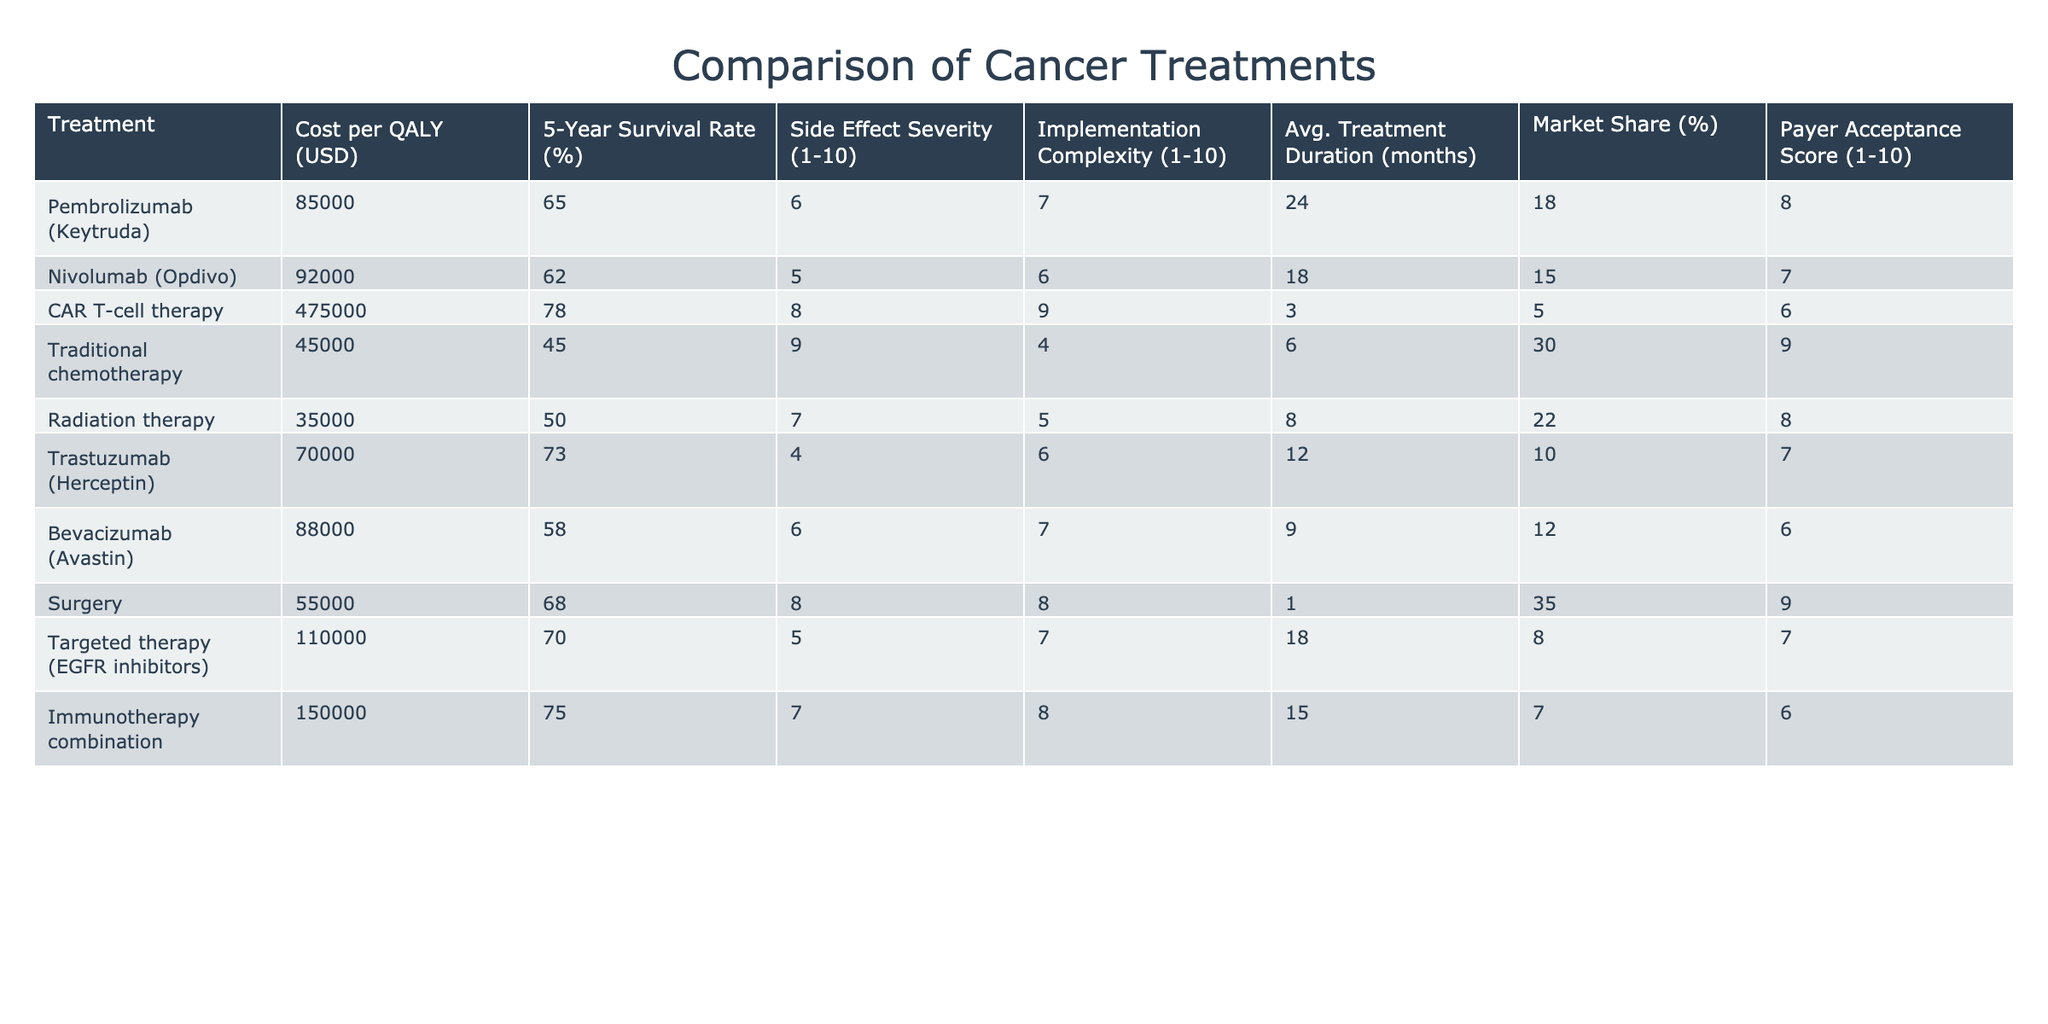What is the cost per QALY for Traditional chemotherapy? The table shows the cost per QALY for Traditional chemotherapy as 45000 USD.
Answer: 45000 Which treatment has the highest 5-Year Survival Rate? The highest 5-Year Survival Rate in the table belongs to CAR T-cell therapy at 78%.
Answer: 78% Is the average treatment duration for Immunotherapy combination longer than that for Radiation therapy? The average treatment duration for Immunotherapy combination is 15 months, while for Radiation therapy, it is 8 months. Since 15 is greater than 8, the statement is true.
Answer: Yes Calculate the average cost per QALY of the treatments listed. The cost per QALY values are: 85000, 92000, 475000, 45000, 35000, 70000, 88000, 55000, 110000, and 150000. Summing them gives  85000 + 92000 + 475000 + 45000 + 35000 + 70000 + 88000 + 55000 + 110000 + 150000 = 1005000. Dividing by the number of treatments (10) gives an average of 1005000/10 = 100500.
Answer: 100500 Does Surgery have a higher Payer Acceptance Score than Targeted therapy (EGFR inhibitors)? The Payer Acceptance Score for Surgery is 9, while for Targeted therapy (EGFR inhibitors), it is 7. Since 9 is greater than 7, the statement is true.
Answer: Yes Which treatment has the lowest Side Effect Severity score, and what is that score? The lowest Side Effect Severity score in the table is for Trastuzumab (Herceptin) with a score of 4.
Answer: 4 If we consider only the treatments with a 5-Year Survival Rate above 70%, what is the average cost per QALY for these treatments? The treatments with a 5-Year Survival Rate above 70% are Pembrolizumab (85000), CAR T-cell therapy (475000), Trastuzumab (70000), and Immunotherapy combination (150000). The costs are: 85000, 475000, 70000, and 150000. Adding these gives a total of 85000 + 475000 + 70000 + 150000 = 690000. Dividing by the number of treatments (4), the average cost per QALY is 690000/4 = 172500.
Answer: 172500 How does the side effect severity of Traditional chemotherapy compare to that of Pembrolizumab? Traditional chemotherapy has a Side Effect Severity score of 9, while Pembrolizumab has a score of 6. Since 9 is greater than 6, Traditional chemotherapy has a higher severity.
Answer: Higher 